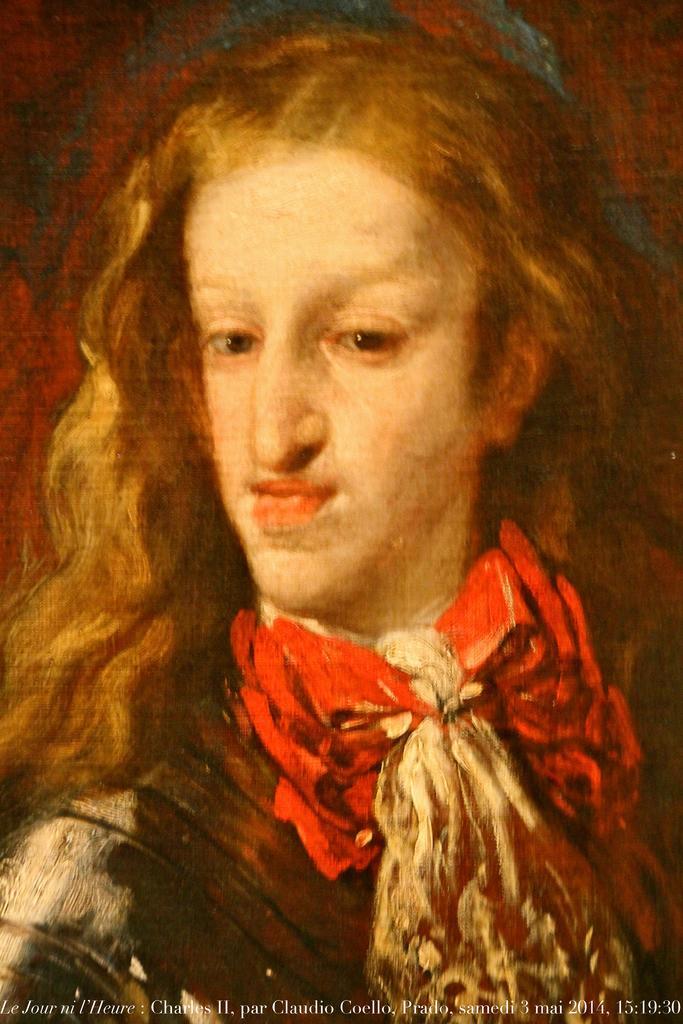Describe this image in one or two sentences. In this image there is a painting of a person, at the bottom of the image there is some text. 